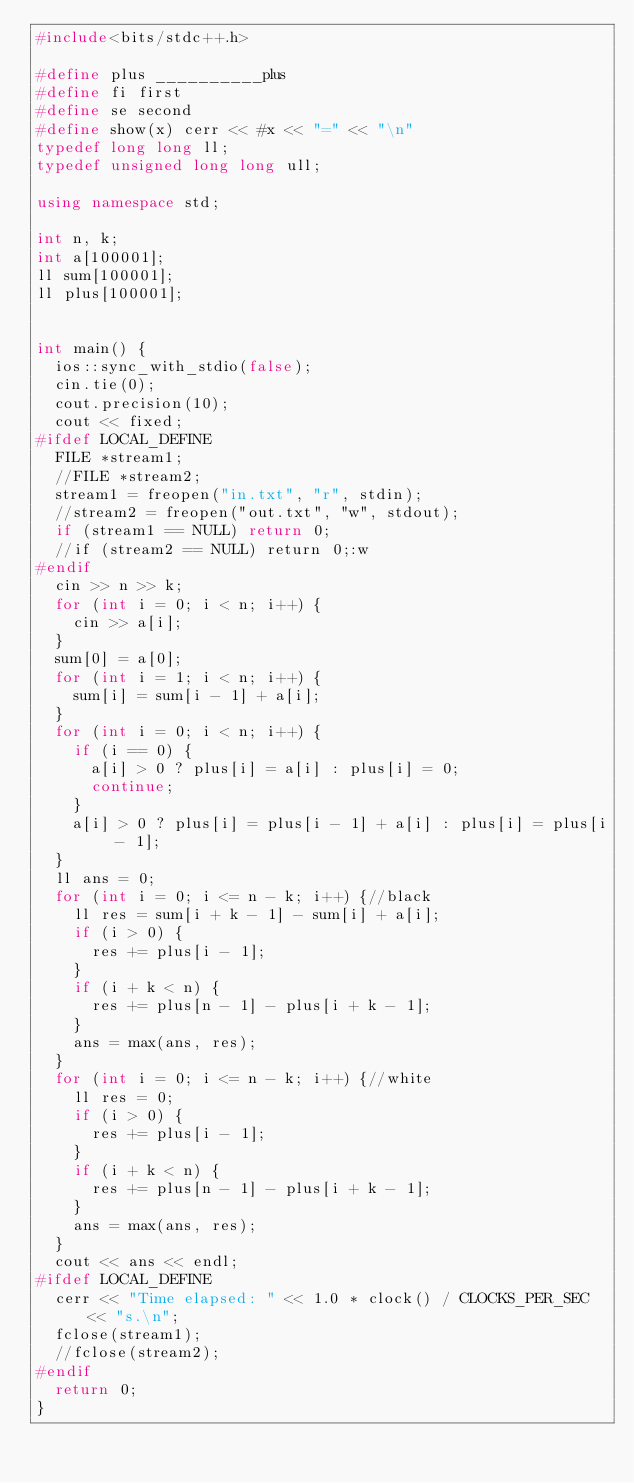Convert code to text. <code><loc_0><loc_0><loc_500><loc_500><_C++_>#include<bits/stdc++.h>

#define plus __________plus
#define fi first
#define se second
#define show(x) cerr << #x << "=" << "\n"
typedef long long ll;
typedef unsigned long long ull;

using namespace std;

int n, k;
int a[100001];
ll sum[100001];
ll plus[100001];


int main() {
  ios::sync_with_stdio(false);
  cin.tie(0);
  cout.precision(10);
  cout << fixed;
#ifdef LOCAL_DEFINE
  FILE *stream1;
  //FILE *stream2;
  stream1 = freopen("in.txt", "r", stdin);
  //stream2 = freopen("out.txt", "w", stdout);
  if (stream1 == NULL) return 0;
  //if (stream2 == NULL) return 0;:w
#endif
  cin >> n >> k;
  for (int i = 0; i < n; i++) {
    cin >> a[i];
  }
  sum[0] = a[0];
  for (int i = 1; i < n; i++) {
    sum[i] = sum[i - 1] + a[i];
  }
  for (int i = 0; i < n; i++) {
    if (i == 0) {
      a[i] > 0 ? plus[i] = a[i] : plus[i] = 0;
      continue;
    }
    a[i] > 0 ? plus[i] = plus[i - 1] + a[i] : plus[i] = plus[i - 1];
  }
  ll ans = 0;
  for (int i = 0; i <= n - k; i++) {//black
    ll res = sum[i + k - 1] - sum[i] + a[i];
    if (i > 0) {
      res += plus[i - 1];
    }
    if (i + k < n) {
      res += plus[n - 1] - plus[i + k - 1];
    }
    ans = max(ans, res);
  }
  for (int i = 0; i <= n - k; i++) {//white
    ll res = 0;
    if (i > 0) {
      res += plus[i - 1];
    }
    if (i + k < n) {
      res += plus[n - 1] - plus[i + k - 1];
    }
    ans = max(ans, res);
  }
  cout << ans << endl;
#ifdef LOCAL_DEFINE
  cerr << "Time elapsed: " << 1.0 * clock() / CLOCKS_PER_SEC << "s.\n";
  fclose(stream1);
  //fclose(stream2);
#endif
  return 0;
}</code> 